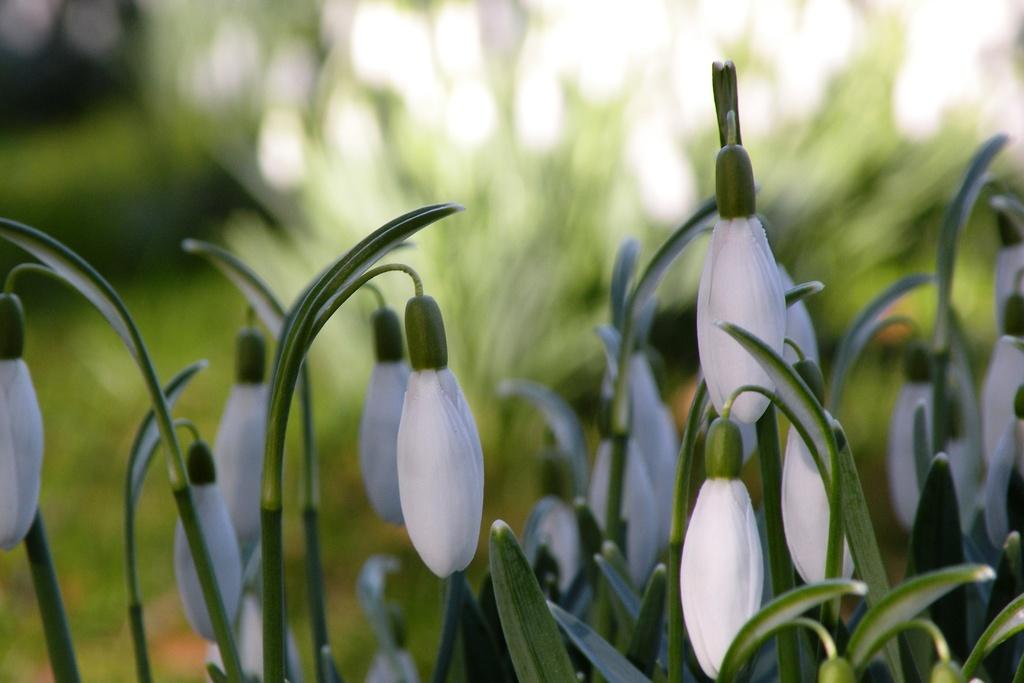What type of plants are featured in the image? There are many leucojum plants in the image. What do the flowers of these plants look like? The plants have beautiful white flowers. Can you describe the background of the image? The background of the image is blurred. What type of lumber can be seen in the image? There is no lumber present in the image; it features leucojum plants with white flowers. How many planes are visible in the image? There are no planes visible in the image. 